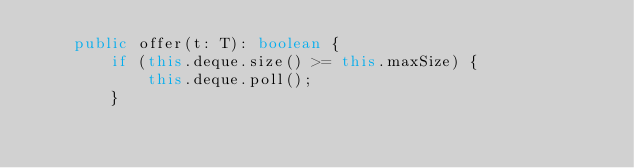Convert code to text. <code><loc_0><loc_0><loc_500><loc_500><_TypeScript_>    public offer(t: T): boolean {
        if (this.deque.size() >= this.maxSize) {
            this.deque.poll();
        }</code> 